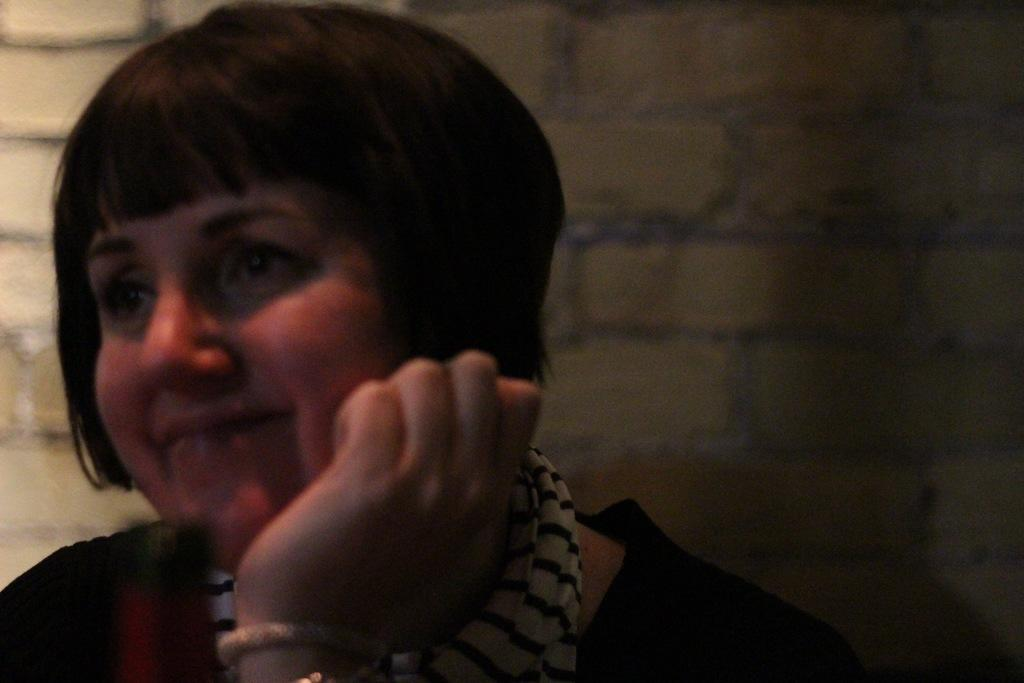Who is present in the image? There is a woman in the image. What expression does the woman have? The woman is smiling. What can be seen in the background of the image? There is a wall in the background of the image. What type of straw is the woman using to eat her pancake in the image? There is no straw or pancake present in the image; it features a woman smiling with a wall in the background. What rule is the woman breaking in the image? There is no indication in the image that the woman is breaking any rules. 